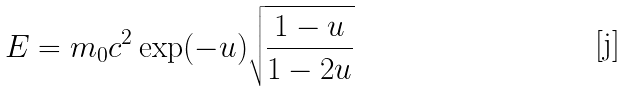Convert formula to latex. <formula><loc_0><loc_0><loc_500><loc_500>E = m _ { 0 } c ^ { 2 } \exp ( - u ) \sqrt { \frac { 1 - u } { 1 - 2 u } }</formula> 